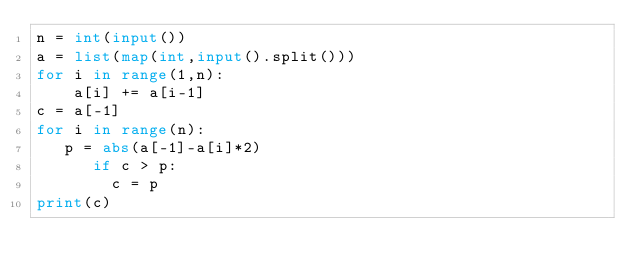<code> <loc_0><loc_0><loc_500><loc_500><_Python_>n = int(input())
a = list(map(int,input().split()))
for i in range(1,n):
    a[i] += a[i-1]
c = a[-1]
for i in range(n):
   p = abs(a[-1]-a[i]*2)
      if c > p:
        c = p   
print(c) </code> 